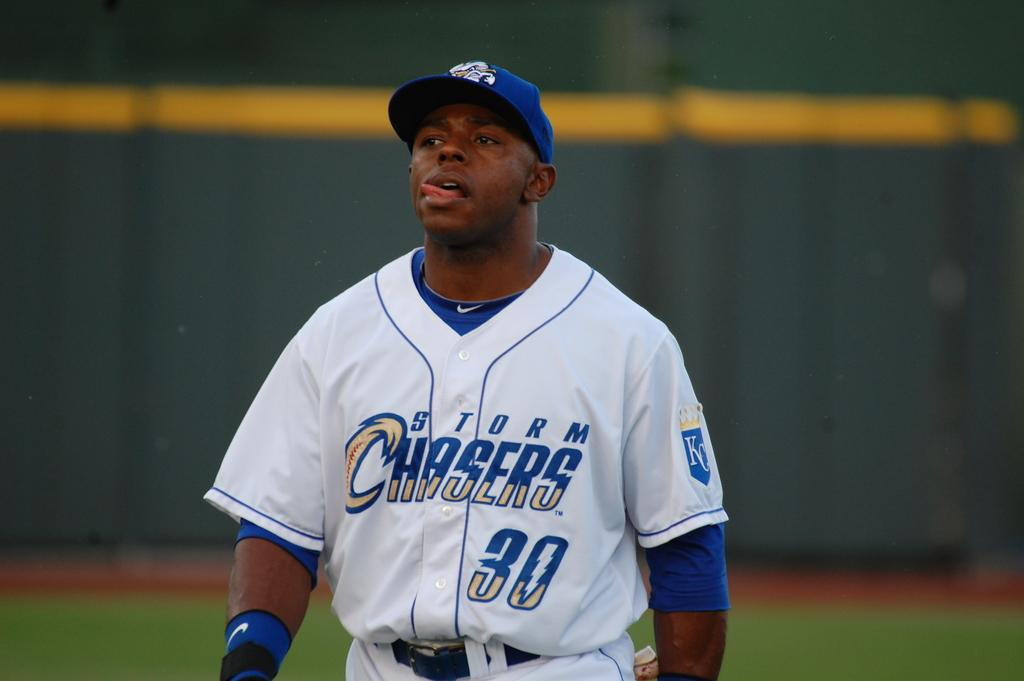<image>
Relay a brief, clear account of the picture shown. A man wearing a Storm Chasers baseball uniform is sticking out his tongue. 